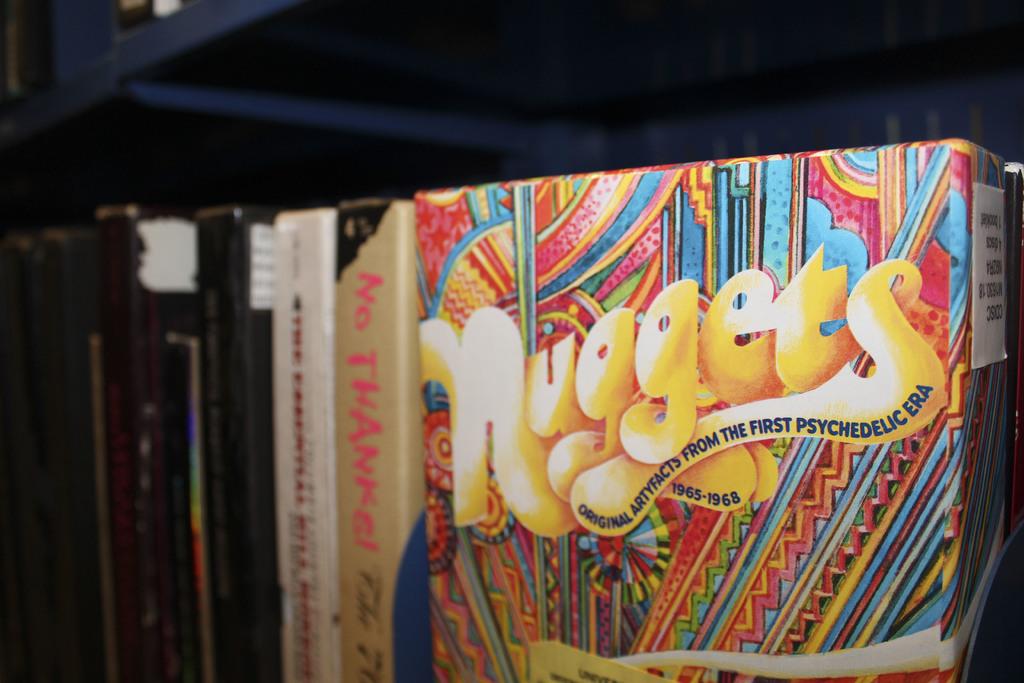What's the biggest word on the album cover?
Provide a short and direct response. Nuggets. What is the first letter in the title of this?
Ensure brevity in your answer.  N. 